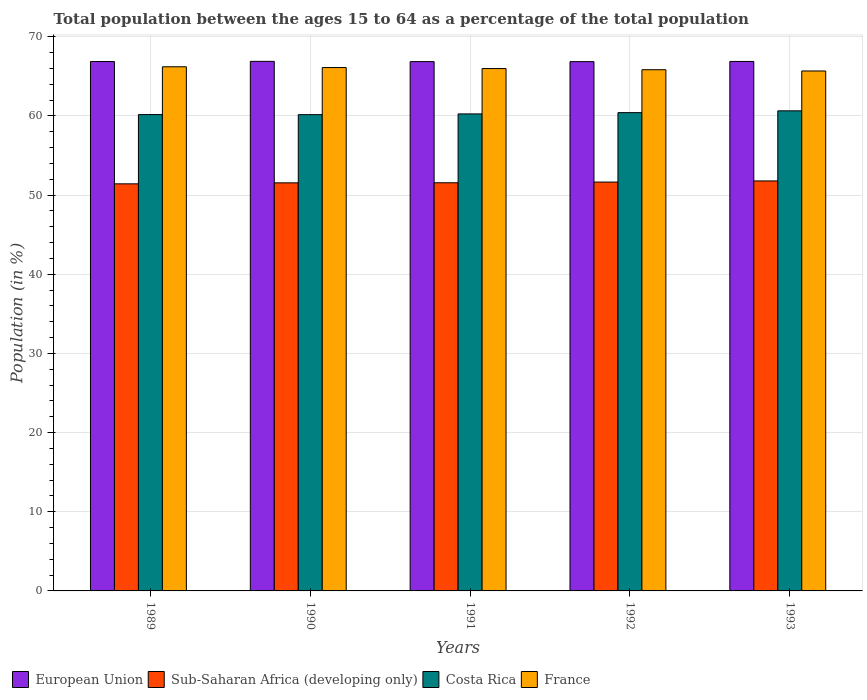How many different coloured bars are there?
Make the answer very short. 4. How many groups of bars are there?
Give a very brief answer. 5. Are the number of bars per tick equal to the number of legend labels?
Provide a succinct answer. Yes. Are the number of bars on each tick of the X-axis equal?
Give a very brief answer. Yes. How many bars are there on the 2nd tick from the left?
Provide a succinct answer. 4. In how many cases, is the number of bars for a given year not equal to the number of legend labels?
Your answer should be compact. 0. What is the percentage of the population ages 15 to 64 in Sub-Saharan Africa (developing only) in 1989?
Keep it short and to the point. 51.43. Across all years, what is the maximum percentage of the population ages 15 to 64 in France?
Ensure brevity in your answer.  66.22. Across all years, what is the minimum percentage of the population ages 15 to 64 in Sub-Saharan Africa (developing only)?
Make the answer very short. 51.43. In which year was the percentage of the population ages 15 to 64 in France maximum?
Your response must be concise. 1989. What is the total percentage of the population ages 15 to 64 in France in the graph?
Provide a short and direct response. 329.86. What is the difference between the percentage of the population ages 15 to 64 in European Union in 1990 and that in 1992?
Provide a short and direct response. 0.04. What is the difference between the percentage of the population ages 15 to 64 in Sub-Saharan Africa (developing only) in 1989 and the percentage of the population ages 15 to 64 in European Union in 1990?
Keep it short and to the point. -15.47. What is the average percentage of the population ages 15 to 64 in European Union per year?
Make the answer very short. 66.88. In the year 1990, what is the difference between the percentage of the population ages 15 to 64 in Costa Rica and percentage of the population ages 15 to 64 in Sub-Saharan Africa (developing only)?
Offer a terse response. 8.62. What is the ratio of the percentage of the population ages 15 to 64 in Costa Rica in 1989 to that in 1990?
Offer a terse response. 1. Is the percentage of the population ages 15 to 64 in France in 1989 less than that in 1990?
Offer a very short reply. No. What is the difference between the highest and the second highest percentage of the population ages 15 to 64 in France?
Keep it short and to the point. 0.1. What is the difference between the highest and the lowest percentage of the population ages 15 to 64 in European Union?
Provide a succinct answer. 0.04. In how many years, is the percentage of the population ages 15 to 64 in Costa Rica greater than the average percentage of the population ages 15 to 64 in Costa Rica taken over all years?
Give a very brief answer. 2. What does the 3rd bar from the left in 1992 represents?
Offer a terse response. Costa Rica. What does the 1st bar from the right in 1991 represents?
Provide a short and direct response. France. Are all the bars in the graph horizontal?
Keep it short and to the point. No. How many years are there in the graph?
Your response must be concise. 5. What is the difference between two consecutive major ticks on the Y-axis?
Provide a succinct answer. 10. Where does the legend appear in the graph?
Provide a short and direct response. Bottom left. How are the legend labels stacked?
Give a very brief answer. Horizontal. What is the title of the graph?
Make the answer very short. Total population between the ages 15 to 64 as a percentage of the total population. Does "France" appear as one of the legend labels in the graph?
Make the answer very short. Yes. What is the Population (in %) in European Union in 1989?
Your answer should be very brief. 66.88. What is the Population (in %) of Sub-Saharan Africa (developing only) in 1989?
Offer a terse response. 51.43. What is the Population (in %) in Costa Rica in 1989?
Your answer should be very brief. 60.18. What is the Population (in %) in France in 1989?
Ensure brevity in your answer.  66.22. What is the Population (in %) in European Union in 1990?
Your answer should be compact. 66.9. What is the Population (in %) of Sub-Saharan Africa (developing only) in 1990?
Provide a short and direct response. 51.55. What is the Population (in %) of Costa Rica in 1990?
Keep it short and to the point. 60.17. What is the Population (in %) in France in 1990?
Make the answer very short. 66.12. What is the Population (in %) of European Union in 1991?
Your answer should be compact. 66.87. What is the Population (in %) of Sub-Saharan Africa (developing only) in 1991?
Your answer should be very brief. 51.56. What is the Population (in %) of Costa Rica in 1991?
Provide a succinct answer. 60.26. What is the Population (in %) in France in 1991?
Your response must be concise. 65.99. What is the Population (in %) of European Union in 1992?
Your answer should be very brief. 66.87. What is the Population (in %) of Sub-Saharan Africa (developing only) in 1992?
Give a very brief answer. 51.65. What is the Population (in %) of Costa Rica in 1992?
Offer a very short reply. 60.42. What is the Population (in %) of France in 1992?
Your response must be concise. 65.84. What is the Population (in %) of European Union in 1993?
Give a very brief answer. 66.89. What is the Population (in %) of Sub-Saharan Africa (developing only) in 1993?
Give a very brief answer. 51.8. What is the Population (in %) in Costa Rica in 1993?
Provide a short and direct response. 60.65. What is the Population (in %) of France in 1993?
Ensure brevity in your answer.  65.69. Across all years, what is the maximum Population (in %) of European Union?
Your answer should be very brief. 66.9. Across all years, what is the maximum Population (in %) of Sub-Saharan Africa (developing only)?
Keep it short and to the point. 51.8. Across all years, what is the maximum Population (in %) of Costa Rica?
Your response must be concise. 60.65. Across all years, what is the maximum Population (in %) of France?
Give a very brief answer. 66.22. Across all years, what is the minimum Population (in %) of European Union?
Your answer should be compact. 66.87. Across all years, what is the minimum Population (in %) of Sub-Saharan Africa (developing only)?
Make the answer very short. 51.43. Across all years, what is the minimum Population (in %) in Costa Rica?
Your response must be concise. 60.17. Across all years, what is the minimum Population (in %) of France?
Your answer should be compact. 65.69. What is the total Population (in %) of European Union in the graph?
Give a very brief answer. 334.41. What is the total Population (in %) in Sub-Saharan Africa (developing only) in the graph?
Your answer should be very brief. 257.99. What is the total Population (in %) of Costa Rica in the graph?
Offer a very short reply. 301.68. What is the total Population (in %) of France in the graph?
Keep it short and to the point. 329.86. What is the difference between the Population (in %) in European Union in 1989 and that in 1990?
Provide a succinct answer. -0.02. What is the difference between the Population (in %) of Sub-Saharan Africa (developing only) in 1989 and that in 1990?
Offer a very short reply. -0.12. What is the difference between the Population (in %) in Costa Rica in 1989 and that in 1990?
Provide a short and direct response. 0.01. What is the difference between the Population (in %) of France in 1989 and that in 1990?
Your answer should be compact. 0.1. What is the difference between the Population (in %) in European Union in 1989 and that in 1991?
Your answer should be compact. 0.01. What is the difference between the Population (in %) in Sub-Saharan Africa (developing only) in 1989 and that in 1991?
Your answer should be compact. -0.13. What is the difference between the Population (in %) of Costa Rica in 1989 and that in 1991?
Your answer should be very brief. -0.08. What is the difference between the Population (in %) in France in 1989 and that in 1991?
Offer a very short reply. 0.23. What is the difference between the Population (in %) in European Union in 1989 and that in 1992?
Your answer should be very brief. 0.01. What is the difference between the Population (in %) of Sub-Saharan Africa (developing only) in 1989 and that in 1992?
Your response must be concise. -0.22. What is the difference between the Population (in %) in Costa Rica in 1989 and that in 1992?
Provide a succinct answer. -0.24. What is the difference between the Population (in %) of France in 1989 and that in 1992?
Make the answer very short. 0.37. What is the difference between the Population (in %) in European Union in 1989 and that in 1993?
Provide a succinct answer. -0.01. What is the difference between the Population (in %) of Sub-Saharan Africa (developing only) in 1989 and that in 1993?
Offer a terse response. -0.37. What is the difference between the Population (in %) of Costa Rica in 1989 and that in 1993?
Offer a very short reply. -0.47. What is the difference between the Population (in %) in France in 1989 and that in 1993?
Offer a terse response. 0.53. What is the difference between the Population (in %) in European Union in 1990 and that in 1991?
Provide a short and direct response. 0.03. What is the difference between the Population (in %) of Sub-Saharan Africa (developing only) in 1990 and that in 1991?
Offer a terse response. -0.01. What is the difference between the Population (in %) of Costa Rica in 1990 and that in 1991?
Offer a very short reply. -0.09. What is the difference between the Population (in %) in France in 1990 and that in 1991?
Provide a succinct answer. 0.13. What is the difference between the Population (in %) of European Union in 1990 and that in 1992?
Your response must be concise. 0.04. What is the difference between the Population (in %) of Sub-Saharan Africa (developing only) in 1990 and that in 1992?
Your answer should be compact. -0.1. What is the difference between the Population (in %) of Costa Rica in 1990 and that in 1992?
Make the answer very short. -0.25. What is the difference between the Population (in %) in France in 1990 and that in 1992?
Ensure brevity in your answer.  0.27. What is the difference between the Population (in %) of European Union in 1990 and that in 1993?
Your answer should be very brief. 0.01. What is the difference between the Population (in %) in Sub-Saharan Africa (developing only) in 1990 and that in 1993?
Your answer should be compact. -0.24. What is the difference between the Population (in %) of Costa Rica in 1990 and that in 1993?
Offer a terse response. -0.48. What is the difference between the Population (in %) of France in 1990 and that in 1993?
Offer a terse response. 0.43. What is the difference between the Population (in %) in European Union in 1991 and that in 1992?
Provide a succinct answer. 0. What is the difference between the Population (in %) in Sub-Saharan Africa (developing only) in 1991 and that in 1992?
Keep it short and to the point. -0.09. What is the difference between the Population (in %) in Costa Rica in 1991 and that in 1992?
Provide a succinct answer. -0.16. What is the difference between the Population (in %) in France in 1991 and that in 1992?
Give a very brief answer. 0.15. What is the difference between the Population (in %) of European Union in 1991 and that in 1993?
Your answer should be very brief. -0.02. What is the difference between the Population (in %) of Sub-Saharan Africa (developing only) in 1991 and that in 1993?
Keep it short and to the point. -0.23. What is the difference between the Population (in %) in Costa Rica in 1991 and that in 1993?
Make the answer very short. -0.39. What is the difference between the Population (in %) in France in 1991 and that in 1993?
Provide a succinct answer. 0.3. What is the difference between the Population (in %) in European Union in 1992 and that in 1993?
Give a very brief answer. -0.02. What is the difference between the Population (in %) of Sub-Saharan Africa (developing only) in 1992 and that in 1993?
Offer a terse response. -0.14. What is the difference between the Population (in %) in Costa Rica in 1992 and that in 1993?
Your answer should be very brief. -0.23. What is the difference between the Population (in %) in France in 1992 and that in 1993?
Make the answer very short. 0.16. What is the difference between the Population (in %) in European Union in 1989 and the Population (in %) in Sub-Saharan Africa (developing only) in 1990?
Offer a terse response. 15.33. What is the difference between the Population (in %) in European Union in 1989 and the Population (in %) in Costa Rica in 1990?
Give a very brief answer. 6.71. What is the difference between the Population (in %) of European Union in 1989 and the Population (in %) of France in 1990?
Provide a succinct answer. 0.76. What is the difference between the Population (in %) of Sub-Saharan Africa (developing only) in 1989 and the Population (in %) of Costa Rica in 1990?
Your response must be concise. -8.74. What is the difference between the Population (in %) in Sub-Saharan Africa (developing only) in 1989 and the Population (in %) in France in 1990?
Offer a very short reply. -14.69. What is the difference between the Population (in %) of Costa Rica in 1989 and the Population (in %) of France in 1990?
Provide a short and direct response. -5.94. What is the difference between the Population (in %) of European Union in 1989 and the Population (in %) of Sub-Saharan Africa (developing only) in 1991?
Your answer should be compact. 15.32. What is the difference between the Population (in %) of European Union in 1989 and the Population (in %) of Costa Rica in 1991?
Offer a terse response. 6.62. What is the difference between the Population (in %) of European Union in 1989 and the Population (in %) of France in 1991?
Your response must be concise. 0.89. What is the difference between the Population (in %) in Sub-Saharan Africa (developing only) in 1989 and the Population (in %) in Costa Rica in 1991?
Keep it short and to the point. -8.83. What is the difference between the Population (in %) in Sub-Saharan Africa (developing only) in 1989 and the Population (in %) in France in 1991?
Your answer should be very brief. -14.56. What is the difference between the Population (in %) in Costa Rica in 1989 and the Population (in %) in France in 1991?
Provide a succinct answer. -5.81. What is the difference between the Population (in %) of European Union in 1989 and the Population (in %) of Sub-Saharan Africa (developing only) in 1992?
Ensure brevity in your answer.  15.23. What is the difference between the Population (in %) in European Union in 1989 and the Population (in %) in Costa Rica in 1992?
Give a very brief answer. 6.46. What is the difference between the Population (in %) in European Union in 1989 and the Population (in %) in France in 1992?
Provide a succinct answer. 1.04. What is the difference between the Population (in %) in Sub-Saharan Africa (developing only) in 1989 and the Population (in %) in Costa Rica in 1992?
Offer a very short reply. -8.99. What is the difference between the Population (in %) in Sub-Saharan Africa (developing only) in 1989 and the Population (in %) in France in 1992?
Ensure brevity in your answer.  -14.41. What is the difference between the Population (in %) of Costa Rica in 1989 and the Population (in %) of France in 1992?
Give a very brief answer. -5.66. What is the difference between the Population (in %) of European Union in 1989 and the Population (in %) of Sub-Saharan Africa (developing only) in 1993?
Your answer should be compact. 15.08. What is the difference between the Population (in %) in European Union in 1989 and the Population (in %) in Costa Rica in 1993?
Your answer should be very brief. 6.23. What is the difference between the Population (in %) of European Union in 1989 and the Population (in %) of France in 1993?
Your response must be concise. 1.19. What is the difference between the Population (in %) of Sub-Saharan Africa (developing only) in 1989 and the Population (in %) of Costa Rica in 1993?
Your answer should be very brief. -9.22. What is the difference between the Population (in %) of Sub-Saharan Africa (developing only) in 1989 and the Population (in %) of France in 1993?
Your response must be concise. -14.26. What is the difference between the Population (in %) of Costa Rica in 1989 and the Population (in %) of France in 1993?
Your response must be concise. -5.51. What is the difference between the Population (in %) of European Union in 1990 and the Population (in %) of Sub-Saharan Africa (developing only) in 1991?
Your answer should be compact. 15.34. What is the difference between the Population (in %) of European Union in 1990 and the Population (in %) of Costa Rica in 1991?
Offer a very short reply. 6.64. What is the difference between the Population (in %) in European Union in 1990 and the Population (in %) in France in 1991?
Your answer should be compact. 0.91. What is the difference between the Population (in %) of Sub-Saharan Africa (developing only) in 1990 and the Population (in %) of Costa Rica in 1991?
Give a very brief answer. -8.71. What is the difference between the Population (in %) in Sub-Saharan Africa (developing only) in 1990 and the Population (in %) in France in 1991?
Offer a very short reply. -14.44. What is the difference between the Population (in %) in Costa Rica in 1990 and the Population (in %) in France in 1991?
Your answer should be very brief. -5.82. What is the difference between the Population (in %) of European Union in 1990 and the Population (in %) of Sub-Saharan Africa (developing only) in 1992?
Your answer should be very brief. 15.25. What is the difference between the Population (in %) of European Union in 1990 and the Population (in %) of Costa Rica in 1992?
Make the answer very short. 6.48. What is the difference between the Population (in %) in European Union in 1990 and the Population (in %) in France in 1992?
Your response must be concise. 1.06. What is the difference between the Population (in %) in Sub-Saharan Africa (developing only) in 1990 and the Population (in %) in Costa Rica in 1992?
Provide a short and direct response. -8.87. What is the difference between the Population (in %) in Sub-Saharan Africa (developing only) in 1990 and the Population (in %) in France in 1992?
Offer a terse response. -14.29. What is the difference between the Population (in %) of Costa Rica in 1990 and the Population (in %) of France in 1992?
Make the answer very short. -5.67. What is the difference between the Population (in %) of European Union in 1990 and the Population (in %) of Sub-Saharan Africa (developing only) in 1993?
Give a very brief answer. 15.11. What is the difference between the Population (in %) of European Union in 1990 and the Population (in %) of Costa Rica in 1993?
Make the answer very short. 6.25. What is the difference between the Population (in %) of European Union in 1990 and the Population (in %) of France in 1993?
Offer a very short reply. 1.21. What is the difference between the Population (in %) in Sub-Saharan Africa (developing only) in 1990 and the Population (in %) in Costa Rica in 1993?
Provide a short and direct response. -9.1. What is the difference between the Population (in %) of Sub-Saharan Africa (developing only) in 1990 and the Population (in %) of France in 1993?
Keep it short and to the point. -14.14. What is the difference between the Population (in %) of Costa Rica in 1990 and the Population (in %) of France in 1993?
Offer a terse response. -5.52. What is the difference between the Population (in %) of European Union in 1991 and the Population (in %) of Sub-Saharan Africa (developing only) in 1992?
Provide a succinct answer. 15.22. What is the difference between the Population (in %) in European Union in 1991 and the Population (in %) in Costa Rica in 1992?
Provide a short and direct response. 6.45. What is the difference between the Population (in %) in European Union in 1991 and the Population (in %) in France in 1992?
Provide a short and direct response. 1.02. What is the difference between the Population (in %) of Sub-Saharan Africa (developing only) in 1991 and the Population (in %) of Costa Rica in 1992?
Provide a succinct answer. -8.86. What is the difference between the Population (in %) of Sub-Saharan Africa (developing only) in 1991 and the Population (in %) of France in 1992?
Provide a short and direct response. -14.28. What is the difference between the Population (in %) in Costa Rica in 1991 and the Population (in %) in France in 1992?
Offer a terse response. -5.58. What is the difference between the Population (in %) in European Union in 1991 and the Population (in %) in Sub-Saharan Africa (developing only) in 1993?
Your answer should be very brief. 15.07. What is the difference between the Population (in %) in European Union in 1991 and the Population (in %) in Costa Rica in 1993?
Offer a terse response. 6.22. What is the difference between the Population (in %) of European Union in 1991 and the Population (in %) of France in 1993?
Ensure brevity in your answer.  1.18. What is the difference between the Population (in %) of Sub-Saharan Africa (developing only) in 1991 and the Population (in %) of Costa Rica in 1993?
Your answer should be very brief. -9.09. What is the difference between the Population (in %) of Sub-Saharan Africa (developing only) in 1991 and the Population (in %) of France in 1993?
Your answer should be compact. -14.12. What is the difference between the Population (in %) of Costa Rica in 1991 and the Population (in %) of France in 1993?
Your answer should be very brief. -5.42. What is the difference between the Population (in %) of European Union in 1992 and the Population (in %) of Sub-Saharan Africa (developing only) in 1993?
Ensure brevity in your answer.  15.07. What is the difference between the Population (in %) in European Union in 1992 and the Population (in %) in Costa Rica in 1993?
Provide a short and direct response. 6.22. What is the difference between the Population (in %) of European Union in 1992 and the Population (in %) of France in 1993?
Offer a terse response. 1.18. What is the difference between the Population (in %) of Sub-Saharan Africa (developing only) in 1992 and the Population (in %) of France in 1993?
Provide a succinct answer. -14.04. What is the difference between the Population (in %) of Costa Rica in 1992 and the Population (in %) of France in 1993?
Your answer should be compact. -5.26. What is the average Population (in %) of European Union per year?
Make the answer very short. 66.88. What is the average Population (in %) of Sub-Saharan Africa (developing only) per year?
Your answer should be very brief. 51.6. What is the average Population (in %) in Costa Rica per year?
Provide a short and direct response. 60.34. What is the average Population (in %) in France per year?
Make the answer very short. 65.97. In the year 1989, what is the difference between the Population (in %) in European Union and Population (in %) in Sub-Saharan Africa (developing only)?
Provide a short and direct response. 15.45. In the year 1989, what is the difference between the Population (in %) of European Union and Population (in %) of Costa Rica?
Offer a terse response. 6.7. In the year 1989, what is the difference between the Population (in %) of European Union and Population (in %) of France?
Offer a very short reply. 0.66. In the year 1989, what is the difference between the Population (in %) in Sub-Saharan Africa (developing only) and Population (in %) in Costa Rica?
Offer a terse response. -8.75. In the year 1989, what is the difference between the Population (in %) in Sub-Saharan Africa (developing only) and Population (in %) in France?
Keep it short and to the point. -14.79. In the year 1989, what is the difference between the Population (in %) of Costa Rica and Population (in %) of France?
Offer a very short reply. -6.04. In the year 1990, what is the difference between the Population (in %) of European Union and Population (in %) of Sub-Saharan Africa (developing only)?
Your response must be concise. 15.35. In the year 1990, what is the difference between the Population (in %) in European Union and Population (in %) in Costa Rica?
Ensure brevity in your answer.  6.73. In the year 1990, what is the difference between the Population (in %) of European Union and Population (in %) of France?
Your response must be concise. 0.78. In the year 1990, what is the difference between the Population (in %) of Sub-Saharan Africa (developing only) and Population (in %) of Costa Rica?
Your answer should be very brief. -8.62. In the year 1990, what is the difference between the Population (in %) of Sub-Saharan Africa (developing only) and Population (in %) of France?
Your answer should be very brief. -14.57. In the year 1990, what is the difference between the Population (in %) of Costa Rica and Population (in %) of France?
Provide a short and direct response. -5.95. In the year 1991, what is the difference between the Population (in %) of European Union and Population (in %) of Sub-Saharan Africa (developing only)?
Your answer should be compact. 15.3. In the year 1991, what is the difference between the Population (in %) in European Union and Population (in %) in Costa Rica?
Give a very brief answer. 6.61. In the year 1991, what is the difference between the Population (in %) in European Union and Population (in %) in France?
Your response must be concise. 0.88. In the year 1991, what is the difference between the Population (in %) of Sub-Saharan Africa (developing only) and Population (in %) of Costa Rica?
Your answer should be compact. -8.7. In the year 1991, what is the difference between the Population (in %) of Sub-Saharan Africa (developing only) and Population (in %) of France?
Keep it short and to the point. -14.43. In the year 1991, what is the difference between the Population (in %) of Costa Rica and Population (in %) of France?
Keep it short and to the point. -5.73. In the year 1992, what is the difference between the Population (in %) of European Union and Population (in %) of Sub-Saharan Africa (developing only)?
Offer a very short reply. 15.22. In the year 1992, what is the difference between the Population (in %) of European Union and Population (in %) of Costa Rica?
Provide a short and direct response. 6.44. In the year 1992, what is the difference between the Population (in %) of European Union and Population (in %) of France?
Keep it short and to the point. 1.02. In the year 1992, what is the difference between the Population (in %) of Sub-Saharan Africa (developing only) and Population (in %) of Costa Rica?
Keep it short and to the point. -8.77. In the year 1992, what is the difference between the Population (in %) in Sub-Saharan Africa (developing only) and Population (in %) in France?
Provide a short and direct response. -14.19. In the year 1992, what is the difference between the Population (in %) in Costa Rica and Population (in %) in France?
Your response must be concise. -5.42. In the year 1993, what is the difference between the Population (in %) in European Union and Population (in %) in Sub-Saharan Africa (developing only)?
Provide a short and direct response. 15.1. In the year 1993, what is the difference between the Population (in %) of European Union and Population (in %) of Costa Rica?
Provide a succinct answer. 6.24. In the year 1993, what is the difference between the Population (in %) of European Union and Population (in %) of France?
Provide a short and direct response. 1.2. In the year 1993, what is the difference between the Population (in %) in Sub-Saharan Africa (developing only) and Population (in %) in Costa Rica?
Ensure brevity in your answer.  -8.86. In the year 1993, what is the difference between the Population (in %) in Sub-Saharan Africa (developing only) and Population (in %) in France?
Keep it short and to the point. -13.89. In the year 1993, what is the difference between the Population (in %) of Costa Rica and Population (in %) of France?
Ensure brevity in your answer.  -5.04. What is the ratio of the Population (in %) in European Union in 1989 to that in 1990?
Your answer should be compact. 1. What is the ratio of the Population (in %) in Sub-Saharan Africa (developing only) in 1989 to that in 1990?
Give a very brief answer. 1. What is the ratio of the Population (in %) in Costa Rica in 1989 to that in 1990?
Your answer should be compact. 1. What is the ratio of the Population (in %) in European Union in 1989 to that in 1991?
Your response must be concise. 1. What is the ratio of the Population (in %) in France in 1989 to that in 1991?
Your answer should be compact. 1. What is the ratio of the Population (in %) of Sub-Saharan Africa (developing only) in 1989 to that in 1992?
Provide a succinct answer. 1. What is the ratio of the Population (in %) in Costa Rica in 1989 to that in 1992?
Your response must be concise. 1. What is the ratio of the Population (in %) of European Union in 1989 to that in 1993?
Your answer should be compact. 1. What is the ratio of the Population (in %) in Costa Rica in 1989 to that in 1993?
Provide a succinct answer. 0.99. What is the ratio of the Population (in %) in European Union in 1990 to that in 1991?
Offer a terse response. 1. What is the ratio of the Population (in %) of Costa Rica in 1990 to that in 1991?
Keep it short and to the point. 1. What is the ratio of the Population (in %) of European Union in 1990 to that in 1992?
Provide a succinct answer. 1. What is the ratio of the Population (in %) in France in 1990 to that in 1992?
Give a very brief answer. 1. What is the ratio of the Population (in %) in Costa Rica in 1990 to that in 1993?
Offer a very short reply. 0.99. What is the ratio of the Population (in %) in France in 1990 to that in 1993?
Make the answer very short. 1.01. What is the ratio of the Population (in %) of Sub-Saharan Africa (developing only) in 1991 to that in 1992?
Offer a terse response. 1. What is the ratio of the Population (in %) of France in 1991 to that in 1992?
Provide a short and direct response. 1. What is the ratio of the Population (in %) of European Union in 1991 to that in 1993?
Ensure brevity in your answer.  1. What is the ratio of the Population (in %) in France in 1991 to that in 1993?
Offer a terse response. 1. What is the ratio of the Population (in %) in Costa Rica in 1992 to that in 1993?
Provide a short and direct response. 1. What is the difference between the highest and the second highest Population (in %) of European Union?
Give a very brief answer. 0.01. What is the difference between the highest and the second highest Population (in %) in Sub-Saharan Africa (developing only)?
Ensure brevity in your answer.  0.14. What is the difference between the highest and the second highest Population (in %) of Costa Rica?
Offer a terse response. 0.23. What is the difference between the highest and the second highest Population (in %) of France?
Provide a succinct answer. 0.1. What is the difference between the highest and the lowest Population (in %) in European Union?
Provide a short and direct response. 0.04. What is the difference between the highest and the lowest Population (in %) in Sub-Saharan Africa (developing only)?
Make the answer very short. 0.37. What is the difference between the highest and the lowest Population (in %) in Costa Rica?
Provide a short and direct response. 0.48. What is the difference between the highest and the lowest Population (in %) in France?
Ensure brevity in your answer.  0.53. 